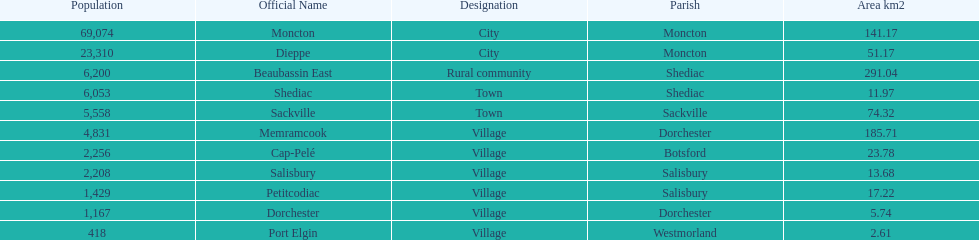How many municipalities have areas that are below 50 square kilometers? 6. 